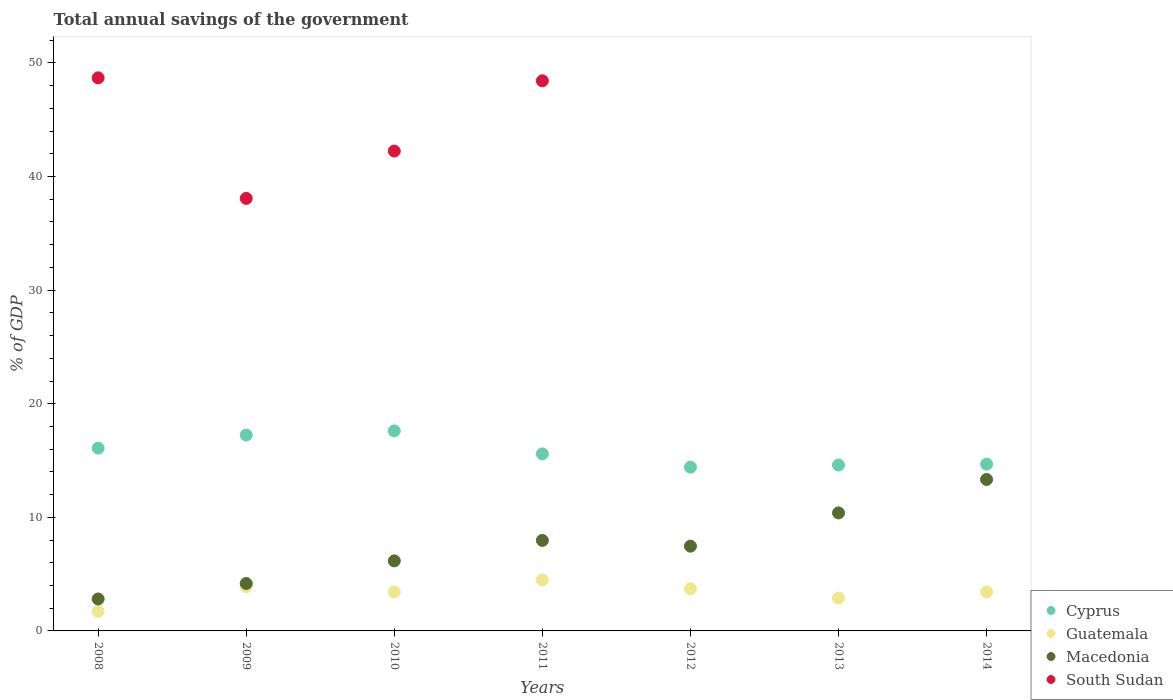How many different coloured dotlines are there?
Keep it short and to the point. 4. Is the number of dotlines equal to the number of legend labels?
Provide a succinct answer. No. What is the total annual savings of the government in Guatemala in 2014?
Provide a succinct answer. 3.43. Across all years, what is the maximum total annual savings of the government in Macedonia?
Provide a succinct answer. 13.33. Across all years, what is the minimum total annual savings of the government in South Sudan?
Make the answer very short. 0. What is the total total annual savings of the government in Cyprus in the graph?
Ensure brevity in your answer.  110.23. What is the difference between the total annual savings of the government in Macedonia in 2012 and that in 2014?
Give a very brief answer. -5.87. What is the difference between the total annual savings of the government in Macedonia in 2009 and the total annual savings of the government in Cyprus in 2010?
Provide a succinct answer. -13.43. What is the average total annual savings of the government in Cyprus per year?
Give a very brief answer. 15.75. In the year 2009, what is the difference between the total annual savings of the government in Guatemala and total annual savings of the government in Macedonia?
Your answer should be very brief. -0.28. What is the ratio of the total annual savings of the government in Cyprus in 2009 to that in 2014?
Your answer should be compact. 1.17. What is the difference between the highest and the second highest total annual savings of the government in South Sudan?
Your response must be concise. 0.26. What is the difference between the highest and the lowest total annual savings of the government in Cyprus?
Give a very brief answer. 3.19. Is it the case that in every year, the sum of the total annual savings of the government in Macedonia and total annual savings of the government in Guatemala  is greater than the total annual savings of the government in South Sudan?
Make the answer very short. No. Is the total annual savings of the government in Cyprus strictly less than the total annual savings of the government in Guatemala over the years?
Ensure brevity in your answer.  No. How many dotlines are there?
Your response must be concise. 4. Are the values on the major ticks of Y-axis written in scientific E-notation?
Offer a very short reply. No. Does the graph contain grids?
Offer a terse response. No. Where does the legend appear in the graph?
Give a very brief answer. Bottom right. How many legend labels are there?
Keep it short and to the point. 4. What is the title of the graph?
Offer a very short reply. Total annual savings of the government. Does "Central Europe" appear as one of the legend labels in the graph?
Your answer should be compact. No. What is the label or title of the X-axis?
Make the answer very short. Years. What is the label or title of the Y-axis?
Keep it short and to the point. % of GDP. What is the % of GDP of Cyprus in 2008?
Provide a short and direct response. 16.09. What is the % of GDP of Guatemala in 2008?
Offer a very short reply. 1.71. What is the % of GDP of Macedonia in 2008?
Offer a terse response. 2.81. What is the % of GDP in South Sudan in 2008?
Your answer should be compact. 48.69. What is the % of GDP in Cyprus in 2009?
Offer a very short reply. 17.24. What is the % of GDP of Guatemala in 2009?
Your answer should be very brief. 3.9. What is the % of GDP of Macedonia in 2009?
Your answer should be compact. 4.18. What is the % of GDP in South Sudan in 2009?
Offer a very short reply. 38.08. What is the % of GDP of Cyprus in 2010?
Ensure brevity in your answer.  17.61. What is the % of GDP of Guatemala in 2010?
Give a very brief answer. 3.43. What is the % of GDP in Macedonia in 2010?
Your response must be concise. 6.17. What is the % of GDP in South Sudan in 2010?
Give a very brief answer. 42.24. What is the % of GDP of Cyprus in 2011?
Give a very brief answer. 15.59. What is the % of GDP in Guatemala in 2011?
Make the answer very short. 4.5. What is the % of GDP in Macedonia in 2011?
Your answer should be compact. 7.97. What is the % of GDP of South Sudan in 2011?
Your answer should be very brief. 48.43. What is the % of GDP in Cyprus in 2012?
Offer a terse response. 14.42. What is the % of GDP of Guatemala in 2012?
Provide a succinct answer. 3.71. What is the % of GDP of Macedonia in 2012?
Make the answer very short. 7.46. What is the % of GDP of South Sudan in 2012?
Keep it short and to the point. 0. What is the % of GDP of Cyprus in 2013?
Provide a short and direct response. 14.6. What is the % of GDP of Guatemala in 2013?
Keep it short and to the point. 2.9. What is the % of GDP of Macedonia in 2013?
Keep it short and to the point. 10.39. What is the % of GDP in South Sudan in 2013?
Make the answer very short. 0. What is the % of GDP of Cyprus in 2014?
Provide a succinct answer. 14.68. What is the % of GDP of Guatemala in 2014?
Offer a terse response. 3.43. What is the % of GDP in Macedonia in 2014?
Make the answer very short. 13.33. What is the % of GDP of South Sudan in 2014?
Give a very brief answer. 0. Across all years, what is the maximum % of GDP of Cyprus?
Make the answer very short. 17.61. Across all years, what is the maximum % of GDP of Guatemala?
Your answer should be compact. 4.5. Across all years, what is the maximum % of GDP of Macedonia?
Give a very brief answer. 13.33. Across all years, what is the maximum % of GDP of South Sudan?
Provide a succinct answer. 48.69. Across all years, what is the minimum % of GDP in Cyprus?
Your answer should be very brief. 14.42. Across all years, what is the minimum % of GDP of Guatemala?
Your response must be concise. 1.71. Across all years, what is the minimum % of GDP in Macedonia?
Provide a succinct answer. 2.81. Across all years, what is the minimum % of GDP in South Sudan?
Offer a terse response. 0. What is the total % of GDP of Cyprus in the graph?
Your answer should be very brief. 110.23. What is the total % of GDP of Guatemala in the graph?
Ensure brevity in your answer.  23.58. What is the total % of GDP in Macedonia in the graph?
Your answer should be compact. 52.31. What is the total % of GDP in South Sudan in the graph?
Your response must be concise. 177.44. What is the difference between the % of GDP of Cyprus in 2008 and that in 2009?
Keep it short and to the point. -1.15. What is the difference between the % of GDP in Guatemala in 2008 and that in 2009?
Your response must be concise. -2.18. What is the difference between the % of GDP of Macedonia in 2008 and that in 2009?
Make the answer very short. -1.36. What is the difference between the % of GDP in South Sudan in 2008 and that in 2009?
Your answer should be very brief. 10.61. What is the difference between the % of GDP of Cyprus in 2008 and that in 2010?
Ensure brevity in your answer.  -1.51. What is the difference between the % of GDP in Guatemala in 2008 and that in 2010?
Keep it short and to the point. -1.72. What is the difference between the % of GDP in Macedonia in 2008 and that in 2010?
Offer a terse response. -3.36. What is the difference between the % of GDP in South Sudan in 2008 and that in 2010?
Offer a very short reply. 6.45. What is the difference between the % of GDP of Cyprus in 2008 and that in 2011?
Provide a short and direct response. 0.51. What is the difference between the % of GDP of Guatemala in 2008 and that in 2011?
Offer a very short reply. -2.78. What is the difference between the % of GDP in Macedonia in 2008 and that in 2011?
Keep it short and to the point. -5.16. What is the difference between the % of GDP in South Sudan in 2008 and that in 2011?
Make the answer very short. 0.26. What is the difference between the % of GDP of Cyprus in 2008 and that in 2012?
Offer a very short reply. 1.68. What is the difference between the % of GDP of Guatemala in 2008 and that in 2012?
Your response must be concise. -2. What is the difference between the % of GDP in Macedonia in 2008 and that in 2012?
Provide a short and direct response. -4.65. What is the difference between the % of GDP of Cyprus in 2008 and that in 2013?
Provide a succinct answer. 1.49. What is the difference between the % of GDP in Guatemala in 2008 and that in 2013?
Provide a succinct answer. -1.19. What is the difference between the % of GDP in Macedonia in 2008 and that in 2013?
Give a very brief answer. -7.58. What is the difference between the % of GDP of Cyprus in 2008 and that in 2014?
Keep it short and to the point. 1.41. What is the difference between the % of GDP in Guatemala in 2008 and that in 2014?
Offer a terse response. -1.72. What is the difference between the % of GDP in Macedonia in 2008 and that in 2014?
Your answer should be compact. -10.52. What is the difference between the % of GDP of Cyprus in 2009 and that in 2010?
Your answer should be very brief. -0.36. What is the difference between the % of GDP in Guatemala in 2009 and that in 2010?
Your answer should be compact. 0.46. What is the difference between the % of GDP in Macedonia in 2009 and that in 2010?
Provide a short and direct response. -1.99. What is the difference between the % of GDP in South Sudan in 2009 and that in 2010?
Offer a very short reply. -4.17. What is the difference between the % of GDP in Cyprus in 2009 and that in 2011?
Make the answer very short. 1.66. What is the difference between the % of GDP of Guatemala in 2009 and that in 2011?
Provide a short and direct response. -0.6. What is the difference between the % of GDP of Macedonia in 2009 and that in 2011?
Your response must be concise. -3.79. What is the difference between the % of GDP of South Sudan in 2009 and that in 2011?
Your answer should be compact. -10.35. What is the difference between the % of GDP in Cyprus in 2009 and that in 2012?
Give a very brief answer. 2.83. What is the difference between the % of GDP of Guatemala in 2009 and that in 2012?
Ensure brevity in your answer.  0.19. What is the difference between the % of GDP of Macedonia in 2009 and that in 2012?
Offer a very short reply. -3.28. What is the difference between the % of GDP in Cyprus in 2009 and that in 2013?
Provide a short and direct response. 2.64. What is the difference between the % of GDP of Guatemala in 2009 and that in 2013?
Keep it short and to the point. 1. What is the difference between the % of GDP in Macedonia in 2009 and that in 2013?
Ensure brevity in your answer.  -6.21. What is the difference between the % of GDP of Cyprus in 2009 and that in 2014?
Ensure brevity in your answer.  2.56. What is the difference between the % of GDP of Guatemala in 2009 and that in 2014?
Provide a short and direct response. 0.47. What is the difference between the % of GDP of Macedonia in 2009 and that in 2014?
Offer a very short reply. -9.16. What is the difference between the % of GDP of Cyprus in 2010 and that in 2011?
Your response must be concise. 2.02. What is the difference between the % of GDP of Guatemala in 2010 and that in 2011?
Your answer should be compact. -1.06. What is the difference between the % of GDP of Macedonia in 2010 and that in 2011?
Keep it short and to the point. -1.8. What is the difference between the % of GDP of South Sudan in 2010 and that in 2011?
Your response must be concise. -6.18. What is the difference between the % of GDP in Cyprus in 2010 and that in 2012?
Provide a short and direct response. 3.19. What is the difference between the % of GDP of Guatemala in 2010 and that in 2012?
Provide a short and direct response. -0.28. What is the difference between the % of GDP in Macedonia in 2010 and that in 2012?
Keep it short and to the point. -1.29. What is the difference between the % of GDP in Cyprus in 2010 and that in 2013?
Offer a terse response. 3. What is the difference between the % of GDP of Guatemala in 2010 and that in 2013?
Your response must be concise. 0.53. What is the difference between the % of GDP of Macedonia in 2010 and that in 2013?
Offer a terse response. -4.22. What is the difference between the % of GDP in Cyprus in 2010 and that in 2014?
Your response must be concise. 2.93. What is the difference between the % of GDP of Guatemala in 2010 and that in 2014?
Your answer should be compact. 0.01. What is the difference between the % of GDP of Macedonia in 2010 and that in 2014?
Your response must be concise. -7.17. What is the difference between the % of GDP in Cyprus in 2011 and that in 2012?
Keep it short and to the point. 1.17. What is the difference between the % of GDP in Guatemala in 2011 and that in 2012?
Offer a very short reply. 0.79. What is the difference between the % of GDP in Macedonia in 2011 and that in 2012?
Offer a terse response. 0.51. What is the difference between the % of GDP in Cyprus in 2011 and that in 2013?
Your answer should be very brief. 0.98. What is the difference between the % of GDP of Guatemala in 2011 and that in 2013?
Make the answer very short. 1.6. What is the difference between the % of GDP in Macedonia in 2011 and that in 2013?
Your answer should be compact. -2.42. What is the difference between the % of GDP in Cyprus in 2011 and that in 2014?
Your answer should be very brief. 0.9. What is the difference between the % of GDP of Guatemala in 2011 and that in 2014?
Your answer should be compact. 1.07. What is the difference between the % of GDP of Macedonia in 2011 and that in 2014?
Give a very brief answer. -5.36. What is the difference between the % of GDP in Cyprus in 2012 and that in 2013?
Your answer should be compact. -0.19. What is the difference between the % of GDP in Guatemala in 2012 and that in 2013?
Offer a very short reply. 0.81. What is the difference between the % of GDP in Macedonia in 2012 and that in 2013?
Give a very brief answer. -2.93. What is the difference between the % of GDP in Cyprus in 2012 and that in 2014?
Your answer should be very brief. -0.26. What is the difference between the % of GDP in Guatemala in 2012 and that in 2014?
Your response must be concise. 0.28. What is the difference between the % of GDP of Macedonia in 2012 and that in 2014?
Give a very brief answer. -5.87. What is the difference between the % of GDP of Cyprus in 2013 and that in 2014?
Provide a succinct answer. -0.08. What is the difference between the % of GDP in Guatemala in 2013 and that in 2014?
Keep it short and to the point. -0.53. What is the difference between the % of GDP in Macedonia in 2013 and that in 2014?
Give a very brief answer. -2.95. What is the difference between the % of GDP of Cyprus in 2008 and the % of GDP of Guatemala in 2009?
Provide a short and direct response. 12.2. What is the difference between the % of GDP of Cyprus in 2008 and the % of GDP of Macedonia in 2009?
Your answer should be very brief. 11.92. What is the difference between the % of GDP in Cyprus in 2008 and the % of GDP in South Sudan in 2009?
Ensure brevity in your answer.  -21.98. What is the difference between the % of GDP of Guatemala in 2008 and the % of GDP of Macedonia in 2009?
Your response must be concise. -2.46. What is the difference between the % of GDP of Guatemala in 2008 and the % of GDP of South Sudan in 2009?
Keep it short and to the point. -36.36. What is the difference between the % of GDP of Macedonia in 2008 and the % of GDP of South Sudan in 2009?
Provide a succinct answer. -35.26. What is the difference between the % of GDP in Cyprus in 2008 and the % of GDP in Guatemala in 2010?
Offer a terse response. 12.66. What is the difference between the % of GDP in Cyprus in 2008 and the % of GDP in Macedonia in 2010?
Your answer should be compact. 9.93. What is the difference between the % of GDP in Cyprus in 2008 and the % of GDP in South Sudan in 2010?
Make the answer very short. -26.15. What is the difference between the % of GDP in Guatemala in 2008 and the % of GDP in Macedonia in 2010?
Your answer should be very brief. -4.45. What is the difference between the % of GDP of Guatemala in 2008 and the % of GDP of South Sudan in 2010?
Make the answer very short. -40.53. What is the difference between the % of GDP of Macedonia in 2008 and the % of GDP of South Sudan in 2010?
Provide a succinct answer. -39.43. What is the difference between the % of GDP in Cyprus in 2008 and the % of GDP in Guatemala in 2011?
Your response must be concise. 11.6. What is the difference between the % of GDP of Cyprus in 2008 and the % of GDP of Macedonia in 2011?
Ensure brevity in your answer.  8.12. What is the difference between the % of GDP in Cyprus in 2008 and the % of GDP in South Sudan in 2011?
Keep it short and to the point. -32.33. What is the difference between the % of GDP of Guatemala in 2008 and the % of GDP of Macedonia in 2011?
Provide a short and direct response. -6.26. What is the difference between the % of GDP of Guatemala in 2008 and the % of GDP of South Sudan in 2011?
Your answer should be compact. -46.71. What is the difference between the % of GDP in Macedonia in 2008 and the % of GDP in South Sudan in 2011?
Offer a very short reply. -45.62. What is the difference between the % of GDP in Cyprus in 2008 and the % of GDP in Guatemala in 2012?
Your response must be concise. 12.38. What is the difference between the % of GDP in Cyprus in 2008 and the % of GDP in Macedonia in 2012?
Your answer should be very brief. 8.63. What is the difference between the % of GDP in Guatemala in 2008 and the % of GDP in Macedonia in 2012?
Ensure brevity in your answer.  -5.75. What is the difference between the % of GDP of Cyprus in 2008 and the % of GDP of Guatemala in 2013?
Keep it short and to the point. 13.19. What is the difference between the % of GDP of Cyprus in 2008 and the % of GDP of Macedonia in 2013?
Give a very brief answer. 5.71. What is the difference between the % of GDP of Guatemala in 2008 and the % of GDP of Macedonia in 2013?
Your answer should be very brief. -8.68. What is the difference between the % of GDP in Cyprus in 2008 and the % of GDP in Guatemala in 2014?
Offer a very short reply. 12.67. What is the difference between the % of GDP of Cyprus in 2008 and the % of GDP of Macedonia in 2014?
Your answer should be compact. 2.76. What is the difference between the % of GDP in Guatemala in 2008 and the % of GDP in Macedonia in 2014?
Your answer should be compact. -11.62. What is the difference between the % of GDP of Cyprus in 2009 and the % of GDP of Guatemala in 2010?
Ensure brevity in your answer.  13.81. What is the difference between the % of GDP of Cyprus in 2009 and the % of GDP of Macedonia in 2010?
Provide a short and direct response. 11.08. What is the difference between the % of GDP of Cyprus in 2009 and the % of GDP of South Sudan in 2010?
Make the answer very short. -25. What is the difference between the % of GDP in Guatemala in 2009 and the % of GDP in Macedonia in 2010?
Your answer should be compact. -2.27. What is the difference between the % of GDP in Guatemala in 2009 and the % of GDP in South Sudan in 2010?
Your answer should be compact. -38.34. What is the difference between the % of GDP in Macedonia in 2009 and the % of GDP in South Sudan in 2010?
Offer a very short reply. -38.07. What is the difference between the % of GDP of Cyprus in 2009 and the % of GDP of Guatemala in 2011?
Provide a succinct answer. 12.75. What is the difference between the % of GDP of Cyprus in 2009 and the % of GDP of Macedonia in 2011?
Offer a terse response. 9.27. What is the difference between the % of GDP in Cyprus in 2009 and the % of GDP in South Sudan in 2011?
Your response must be concise. -31.18. What is the difference between the % of GDP in Guatemala in 2009 and the % of GDP in Macedonia in 2011?
Provide a short and direct response. -4.07. What is the difference between the % of GDP of Guatemala in 2009 and the % of GDP of South Sudan in 2011?
Offer a terse response. -44.53. What is the difference between the % of GDP in Macedonia in 2009 and the % of GDP in South Sudan in 2011?
Your answer should be very brief. -44.25. What is the difference between the % of GDP in Cyprus in 2009 and the % of GDP in Guatemala in 2012?
Offer a terse response. 13.53. What is the difference between the % of GDP of Cyprus in 2009 and the % of GDP of Macedonia in 2012?
Give a very brief answer. 9.78. What is the difference between the % of GDP in Guatemala in 2009 and the % of GDP in Macedonia in 2012?
Keep it short and to the point. -3.56. What is the difference between the % of GDP in Cyprus in 2009 and the % of GDP in Guatemala in 2013?
Your answer should be very brief. 14.34. What is the difference between the % of GDP of Cyprus in 2009 and the % of GDP of Macedonia in 2013?
Offer a terse response. 6.85. What is the difference between the % of GDP in Guatemala in 2009 and the % of GDP in Macedonia in 2013?
Keep it short and to the point. -6.49. What is the difference between the % of GDP in Cyprus in 2009 and the % of GDP in Guatemala in 2014?
Provide a succinct answer. 13.81. What is the difference between the % of GDP in Cyprus in 2009 and the % of GDP in Macedonia in 2014?
Keep it short and to the point. 3.91. What is the difference between the % of GDP in Guatemala in 2009 and the % of GDP in Macedonia in 2014?
Provide a succinct answer. -9.44. What is the difference between the % of GDP in Cyprus in 2010 and the % of GDP in Guatemala in 2011?
Keep it short and to the point. 13.11. What is the difference between the % of GDP of Cyprus in 2010 and the % of GDP of Macedonia in 2011?
Your answer should be very brief. 9.64. What is the difference between the % of GDP of Cyprus in 2010 and the % of GDP of South Sudan in 2011?
Give a very brief answer. -30.82. What is the difference between the % of GDP of Guatemala in 2010 and the % of GDP of Macedonia in 2011?
Make the answer very short. -4.54. What is the difference between the % of GDP in Guatemala in 2010 and the % of GDP in South Sudan in 2011?
Offer a terse response. -44.99. What is the difference between the % of GDP in Macedonia in 2010 and the % of GDP in South Sudan in 2011?
Offer a very short reply. -42.26. What is the difference between the % of GDP of Cyprus in 2010 and the % of GDP of Guatemala in 2012?
Your answer should be very brief. 13.9. What is the difference between the % of GDP of Cyprus in 2010 and the % of GDP of Macedonia in 2012?
Keep it short and to the point. 10.15. What is the difference between the % of GDP of Guatemala in 2010 and the % of GDP of Macedonia in 2012?
Make the answer very short. -4.03. What is the difference between the % of GDP in Cyprus in 2010 and the % of GDP in Guatemala in 2013?
Keep it short and to the point. 14.71. What is the difference between the % of GDP of Cyprus in 2010 and the % of GDP of Macedonia in 2013?
Offer a very short reply. 7.22. What is the difference between the % of GDP in Guatemala in 2010 and the % of GDP in Macedonia in 2013?
Your answer should be very brief. -6.95. What is the difference between the % of GDP of Cyprus in 2010 and the % of GDP of Guatemala in 2014?
Offer a terse response. 14.18. What is the difference between the % of GDP in Cyprus in 2010 and the % of GDP in Macedonia in 2014?
Make the answer very short. 4.27. What is the difference between the % of GDP of Guatemala in 2010 and the % of GDP of Macedonia in 2014?
Your response must be concise. -9.9. What is the difference between the % of GDP in Cyprus in 2011 and the % of GDP in Guatemala in 2012?
Ensure brevity in your answer.  11.88. What is the difference between the % of GDP in Cyprus in 2011 and the % of GDP in Macedonia in 2012?
Ensure brevity in your answer.  8.12. What is the difference between the % of GDP in Guatemala in 2011 and the % of GDP in Macedonia in 2012?
Your answer should be compact. -2.96. What is the difference between the % of GDP of Cyprus in 2011 and the % of GDP of Guatemala in 2013?
Keep it short and to the point. 12.69. What is the difference between the % of GDP in Cyprus in 2011 and the % of GDP in Macedonia in 2013?
Your response must be concise. 5.2. What is the difference between the % of GDP of Guatemala in 2011 and the % of GDP of Macedonia in 2013?
Keep it short and to the point. -5.89. What is the difference between the % of GDP of Cyprus in 2011 and the % of GDP of Guatemala in 2014?
Your response must be concise. 12.16. What is the difference between the % of GDP in Cyprus in 2011 and the % of GDP in Macedonia in 2014?
Your response must be concise. 2.25. What is the difference between the % of GDP of Guatemala in 2011 and the % of GDP of Macedonia in 2014?
Make the answer very short. -8.84. What is the difference between the % of GDP in Cyprus in 2012 and the % of GDP in Guatemala in 2013?
Your answer should be compact. 11.52. What is the difference between the % of GDP in Cyprus in 2012 and the % of GDP in Macedonia in 2013?
Your answer should be compact. 4.03. What is the difference between the % of GDP in Guatemala in 2012 and the % of GDP in Macedonia in 2013?
Make the answer very short. -6.68. What is the difference between the % of GDP of Cyprus in 2012 and the % of GDP of Guatemala in 2014?
Give a very brief answer. 10.99. What is the difference between the % of GDP in Cyprus in 2012 and the % of GDP in Macedonia in 2014?
Provide a succinct answer. 1.08. What is the difference between the % of GDP of Guatemala in 2012 and the % of GDP of Macedonia in 2014?
Keep it short and to the point. -9.62. What is the difference between the % of GDP of Cyprus in 2013 and the % of GDP of Guatemala in 2014?
Offer a very short reply. 11.18. What is the difference between the % of GDP in Cyprus in 2013 and the % of GDP in Macedonia in 2014?
Give a very brief answer. 1.27. What is the difference between the % of GDP of Guatemala in 2013 and the % of GDP of Macedonia in 2014?
Keep it short and to the point. -10.43. What is the average % of GDP in Cyprus per year?
Give a very brief answer. 15.75. What is the average % of GDP in Guatemala per year?
Your answer should be compact. 3.37. What is the average % of GDP of Macedonia per year?
Provide a short and direct response. 7.47. What is the average % of GDP of South Sudan per year?
Your answer should be very brief. 25.35. In the year 2008, what is the difference between the % of GDP in Cyprus and % of GDP in Guatemala?
Your response must be concise. 14.38. In the year 2008, what is the difference between the % of GDP in Cyprus and % of GDP in Macedonia?
Make the answer very short. 13.28. In the year 2008, what is the difference between the % of GDP of Cyprus and % of GDP of South Sudan?
Your answer should be very brief. -32.6. In the year 2008, what is the difference between the % of GDP in Guatemala and % of GDP in Macedonia?
Your response must be concise. -1.1. In the year 2008, what is the difference between the % of GDP in Guatemala and % of GDP in South Sudan?
Ensure brevity in your answer.  -46.98. In the year 2008, what is the difference between the % of GDP in Macedonia and % of GDP in South Sudan?
Provide a succinct answer. -45.88. In the year 2009, what is the difference between the % of GDP in Cyprus and % of GDP in Guatemala?
Provide a succinct answer. 13.35. In the year 2009, what is the difference between the % of GDP in Cyprus and % of GDP in Macedonia?
Make the answer very short. 13.07. In the year 2009, what is the difference between the % of GDP in Cyprus and % of GDP in South Sudan?
Your answer should be compact. -20.83. In the year 2009, what is the difference between the % of GDP in Guatemala and % of GDP in Macedonia?
Give a very brief answer. -0.28. In the year 2009, what is the difference between the % of GDP of Guatemala and % of GDP of South Sudan?
Provide a short and direct response. -34.18. In the year 2009, what is the difference between the % of GDP of Macedonia and % of GDP of South Sudan?
Offer a terse response. -33.9. In the year 2010, what is the difference between the % of GDP in Cyprus and % of GDP in Guatemala?
Provide a short and direct response. 14.17. In the year 2010, what is the difference between the % of GDP of Cyprus and % of GDP of Macedonia?
Your response must be concise. 11.44. In the year 2010, what is the difference between the % of GDP in Cyprus and % of GDP in South Sudan?
Your answer should be compact. -24.63. In the year 2010, what is the difference between the % of GDP in Guatemala and % of GDP in Macedonia?
Keep it short and to the point. -2.73. In the year 2010, what is the difference between the % of GDP of Guatemala and % of GDP of South Sudan?
Your answer should be very brief. -38.81. In the year 2010, what is the difference between the % of GDP of Macedonia and % of GDP of South Sudan?
Provide a short and direct response. -36.08. In the year 2011, what is the difference between the % of GDP in Cyprus and % of GDP in Guatemala?
Offer a terse response. 11.09. In the year 2011, what is the difference between the % of GDP of Cyprus and % of GDP of Macedonia?
Keep it short and to the point. 7.62. In the year 2011, what is the difference between the % of GDP of Cyprus and % of GDP of South Sudan?
Your answer should be compact. -32.84. In the year 2011, what is the difference between the % of GDP in Guatemala and % of GDP in Macedonia?
Provide a succinct answer. -3.47. In the year 2011, what is the difference between the % of GDP in Guatemala and % of GDP in South Sudan?
Keep it short and to the point. -43.93. In the year 2011, what is the difference between the % of GDP of Macedonia and % of GDP of South Sudan?
Offer a terse response. -40.46. In the year 2012, what is the difference between the % of GDP of Cyprus and % of GDP of Guatemala?
Your response must be concise. 10.71. In the year 2012, what is the difference between the % of GDP in Cyprus and % of GDP in Macedonia?
Your answer should be compact. 6.96. In the year 2012, what is the difference between the % of GDP of Guatemala and % of GDP of Macedonia?
Make the answer very short. -3.75. In the year 2013, what is the difference between the % of GDP in Cyprus and % of GDP in Guatemala?
Provide a short and direct response. 11.71. In the year 2013, what is the difference between the % of GDP in Cyprus and % of GDP in Macedonia?
Give a very brief answer. 4.22. In the year 2013, what is the difference between the % of GDP of Guatemala and % of GDP of Macedonia?
Your response must be concise. -7.49. In the year 2014, what is the difference between the % of GDP of Cyprus and % of GDP of Guatemala?
Your response must be concise. 11.25. In the year 2014, what is the difference between the % of GDP in Cyprus and % of GDP in Macedonia?
Your answer should be very brief. 1.35. In the year 2014, what is the difference between the % of GDP of Guatemala and % of GDP of Macedonia?
Offer a terse response. -9.91. What is the ratio of the % of GDP in Cyprus in 2008 to that in 2009?
Your answer should be compact. 0.93. What is the ratio of the % of GDP of Guatemala in 2008 to that in 2009?
Make the answer very short. 0.44. What is the ratio of the % of GDP of Macedonia in 2008 to that in 2009?
Provide a succinct answer. 0.67. What is the ratio of the % of GDP of South Sudan in 2008 to that in 2009?
Your response must be concise. 1.28. What is the ratio of the % of GDP in Cyprus in 2008 to that in 2010?
Provide a succinct answer. 0.91. What is the ratio of the % of GDP in Guatemala in 2008 to that in 2010?
Offer a very short reply. 0.5. What is the ratio of the % of GDP in Macedonia in 2008 to that in 2010?
Your answer should be very brief. 0.46. What is the ratio of the % of GDP in South Sudan in 2008 to that in 2010?
Ensure brevity in your answer.  1.15. What is the ratio of the % of GDP in Cyprus in 2008 to that in 2011?
Give a very brief answer. 1.03. What is the ratio of the % of GDP in Guatemala in 2008 to that in 2011?
Provide a succinct answer. 0.38. What is the ratio of the % of GDP in Macedonia in 2008 to that in 2011?
Your answer should be very brief. 0.35. What is the ratio of the % of GDP of South Sudan in 2008 to that in 2011?
Provide a short and direct response. 1.01. What is the ratio of the % of GDP in Cyprus in 2008 to that in 2012?
Give a very brief answer. 1.12. What is the ratio of the % of GDP of Guatemala in 2008 to that in 2012?
Make the answer very short. 0.46. What is the ratio of the % of GDP in Macedonia in 2008 to that in 2012?
Provide a short and direct response. 0.38. What is the ratio of the % of GDP in Cyprus in 2008 to that in 2013?
Keep it short and to the point. 1.1. What is the ratio of the % of GDP of Guatemala in 2008 to that in 2013?
Keep it short and to the point. 0.59. What is the ratio of the % of GDP of Macedonia in 2008 to that in 2013?
Offer a terse response. 0.27. What is the ratio of the % of GDP of Cyprus in 2008 to that in 2014?
Your answer should be very brief. 1.1. What is the ratio of the % of GDP in Guatemala in 2008 to that in 2014?
Offer a terse response. 0.5. What is the ratio of the % of GDP in Macedonia in 2008 to that in 2014?
Your answer should be compact. 0.21. What is the ratio of the % of GDP in Cyprus in 2009 to that in 2010?
Your answer should be compact. 0.98. What is the ratio of the % of GDP of Guatemala in 2009 to that in 2010?
Your answer should be compact. 1.14. What is the ratio of the % of GDP in Macedonia in 2009 to that in 2010?
Ensure brevity in your answer.  0.68. What is the ratio of the % of GDP of South Sudan in 2009 to that in 2010?
Offer a very short reply. 0.9. What is the ratio of the % of GDP in Cyprus in 2009 to that in 2011?
Your answer should be very brief. 1.11. What is the ratio of the % of GDP of Guatemala in 2009 to that in 2011?
Your answer should be very brief. 0.87. What is the ratio of the % of GDP of Macedonia in 2009 to that in 2011?
Offer a terse response. 0.52. What is the ratio of the % of GDP of South Sudan in 2009 to that in 2011?
Your answer should be compact. 0.79. What is the ratio of the % of GDP in Cyprus in 2009 to that in 2012?
Your response must be concise. 1.2. What is the ratio of the % of GDP in Guatemala in 2009 to that in 2012?
Provide a short and direct response. 1.05. What is the ratio of the % of GDP in Macedonia in 2009 to that in 2012?
Make the answer very short. 0.56. What is the ratio of the % of GDP in Cyprus in 2009 to that in 2013?
Offer a terse response. 1.18. What is the ratio of the % of GDP in Guatemala in 2009 to that in 2013?
Your answer should be compact. 1.34. What is the ratio of the % of GDP in Macedonia in 2009 to that in 2013?
Give a very brief answer. 0.4. What is the ratio of the % of GDP in Cyprus in 2009 to that in 2014?
Your answer should be very brief. 1.17. What is the ratio of the % of GDP of Guatemala in 2009 to that in 2014?
Your answer should be very brief. 1.14. What is the ratio of the % of GDP in Macedonia in 2009 to that in 2014?
Make the answer very short. 0.31. What is the ratio of the % of GDP in Cyprus in 2010 to that in 2011?
Give a very brief answer. 1.13. What is the ratio of the % of GDP of Guatemala in 2010 to that in 2011?
Offer a very short reply. 0.76. What is the ratio of the % of GDP of Macedonia in 2010 to that in 2011?
Your answer should be compact. 0.77. What is the ratio of the % of GDP of South Sudan in 2010 to that in 2011?
Provide a succinct answer. 0.87. What is the ratio of the % of GDP of Cyprus in 2010 to that in 2012?
Offer a very short reply. 1.22. What is the ratio of the % of GDP of Guatemala in 2010 to that in 2012?
Your answer should be compact. 0.93. What is the ratio of the % of GDP of Macedonia in 2010 to that in 2012?
Offer a very short reply. 0.83. What is the ratio of the % of GDP of Cyprus in 2010 to that in 2013?
Offer a very short reply. 1.21. What is the ratio of the % of GDP of Guatemala in 2010 to that in 2013?
Your answer should be very brief. 1.18. What is the ratio of the % of GDP in Macedonia in 2010 to that in 2013?
Your answer should be compact. 0.59. What is the ratio of the % of GDP in Cyprus in 2010 to that in 2014?
Give a very brief answer. 1.2. What is the ratio of the % of GDP of Macedonia in 2010 to that in 2014?
Your answer should be very brief. 0.46. What is the ratio of the % of GDP in Cyprus in 2011 to that in 2012?
Your response must be concise. 1.08. What is the ratio of the % of GDP in Guatemala in 2011 to that in 2012?
Offer a very short reply. 1.21. What is the ratio of the % of GDP in Macedonia in 2011 to that in 2012?
Give a very brief answer. 1.07. What is the ratio of the % of GDP of Cyprus in 2011 to that in 2013?
Your answer should be very brief. 1.07. What is the ratio of the % of GDP of Guatemala in 2011 to that in 2013?
Keep it short and to the point. 1.55. What is the ratio of the % of GDP in Macedonia in 2011 to that in 2013?
Keep it short and to the point. 0.77. What is the ratio of the % of GDP in Cyprus in 2011 to that in 2014?
Your answer should be very brief. 1.06. What is the ratio of the % of GDP in Guatemala in 2011 to that in 2014?
Your answer should be very brief. 1.31. What is the ratio of the % of GDP in Macedonia in 2011 to that in 2014?
Provide a succinct answer. 0.6. What is the ratio of the % of GDP of Cyprus in 2012 to that in 2013?
Your response must be concise. 0.99. What is the ratio of the % of GDP of Guatemala in 2012 to that in 2013?
Offer a very short reply. 1.28. What is the ratio of the % of GDP in Macedonia in 2012 to that in 2013?
Your answer should be very brief. 0.72. What is the ratio of the % of GDP of Guatemala in 2012 to that in 2014?
Give a very brief answer. 1.08. What is the ratio of the % of GDP of Macedonia in 2012 to that in 2014?
Your response must be concise. 0.56. What is the ratio of the % of GDP of Guatemala in 2013 to that in 2014?
Your answer should be very brief. 0.85. What is the ratio of the % of GDP of Macedonia in 2013 to that in 2014?
Your answer should be very brief. 0.78. What is the difference between the highest and the second highest % of GDP of Cyprus?
Ensure brevity in your answer.  0.36. What is the difference between the highest and the second highest % of GDP of Guatemala?
Keep it short and to the point. 0.6. What is the difference between the highest and the second highest % of GDP of Macedonia?
Ensure brevity in your answer.  2.95. What is the difference between the highest and the second highest % of GDP of South Sudan?
Keep it short and to the point. 0.26. What is the difference between the highest and the lowest % of GDP of Cyprus?
Provide a short and direct response. 3.19. What is the difference between the highest and the lowest % of GDP in Guatemala?
Provide a succinct answer. 2.78. What is the difference between the highest and the lowest % of GDP in Macedonia?
Your answer should be compact. 10.52. What is the difference between the highest and the lowest % of GDP in South Sudan?
Your response must be concise. 48.69. 